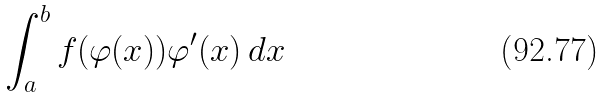<formula> <loc_0><loc_0><loc_500><loc_500>\int _ { a } ^ { b } f ( \varphi ( x ) ) \varphi ^ { \prime } ( x ) \, d x</formula> 